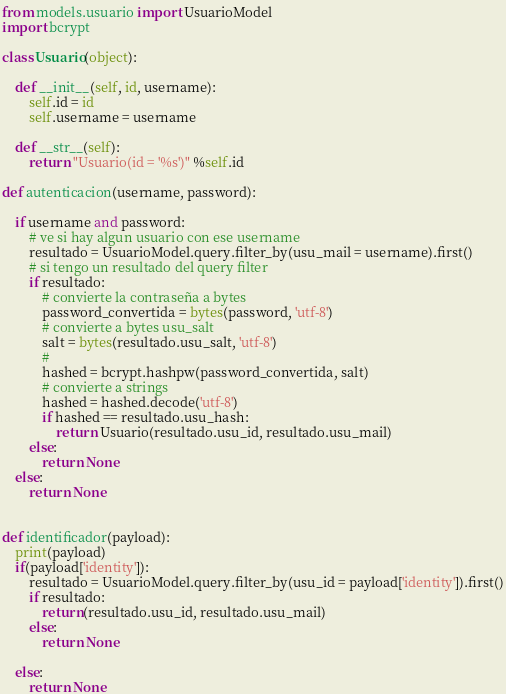Convert code to text. <code><loc_0><loc_0><loc_500><loc_500><_Python_>from models.usuario import UsuarioModel
import bcrypt

class Usuario(object):
    
    def __init__(self, id, username):
        self.id = id
        self.username = username
        
    def __str__(self):
        return "Usuario(id = '%s')" %self.id
    
def autenticacion(username, password):
    
    if username and password:
        # ve si hay algun usuario con ese username
        resultado = UsuarioModel.query.filter_by(usu_mail = username).first()
        # si tengo un resultado del query filter
        if resultado:
            # convierte la contraseña a bytes
            password_convertida = bytes(password, 'utf-8')
            # convierte a bytes usu_salt
            salt = bytes(resultado.usu_salt, 'utf-8')
            # 
            hashed = bcrypt.hashpw(password_convertida, salt)
            # convierte a strings
            hashed = hashed.decode('utf-8')
            if hashed == resultado.usu_hash:
                return Usuario(resultado.usu_id, resultado.usu_mail)
        else:
            return None
    else:
        return None
        

def identificador(payload):
    print(payload)
    if(payload['identity']):
        resultado = UsuarioModel.query.filter_by(usu_id = payload['identity']).first()
        if resultado:
            return(resultado.usu_id, resultado.usu_mail) 
        else:
            return None
        
    else:
        return None       


</code> 